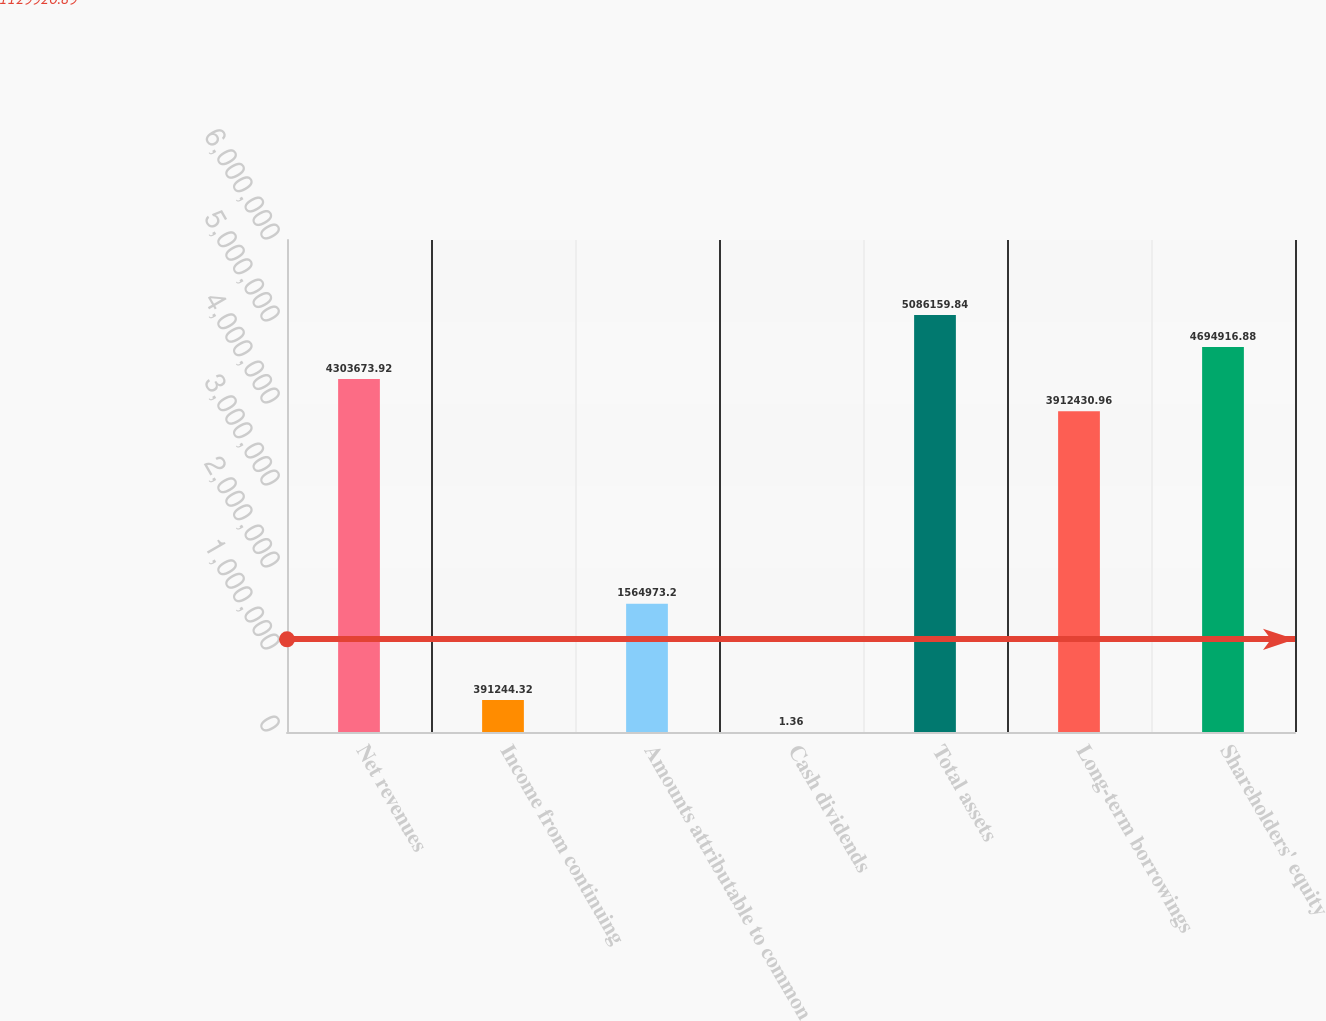Convert chart to OTSL. <chart><loc_0><loc_0><loc_500><loc_500><bar_chart><fcel>Net revenues<fcel>Income from continuing<fcel>Amounts attributable to common<fcel>Cash dividends<fcel>Total assets<fcel>Long-term borrowings<fcel>Shareholders' equity<nl><fcel>4.30367e+06<fcel>391244<fcel>1.56497e+06<fcel>1.36<fcel>5.08616e+06<fcel>3.91243e+06<fcel>4.69492e+06<nl></chart> 